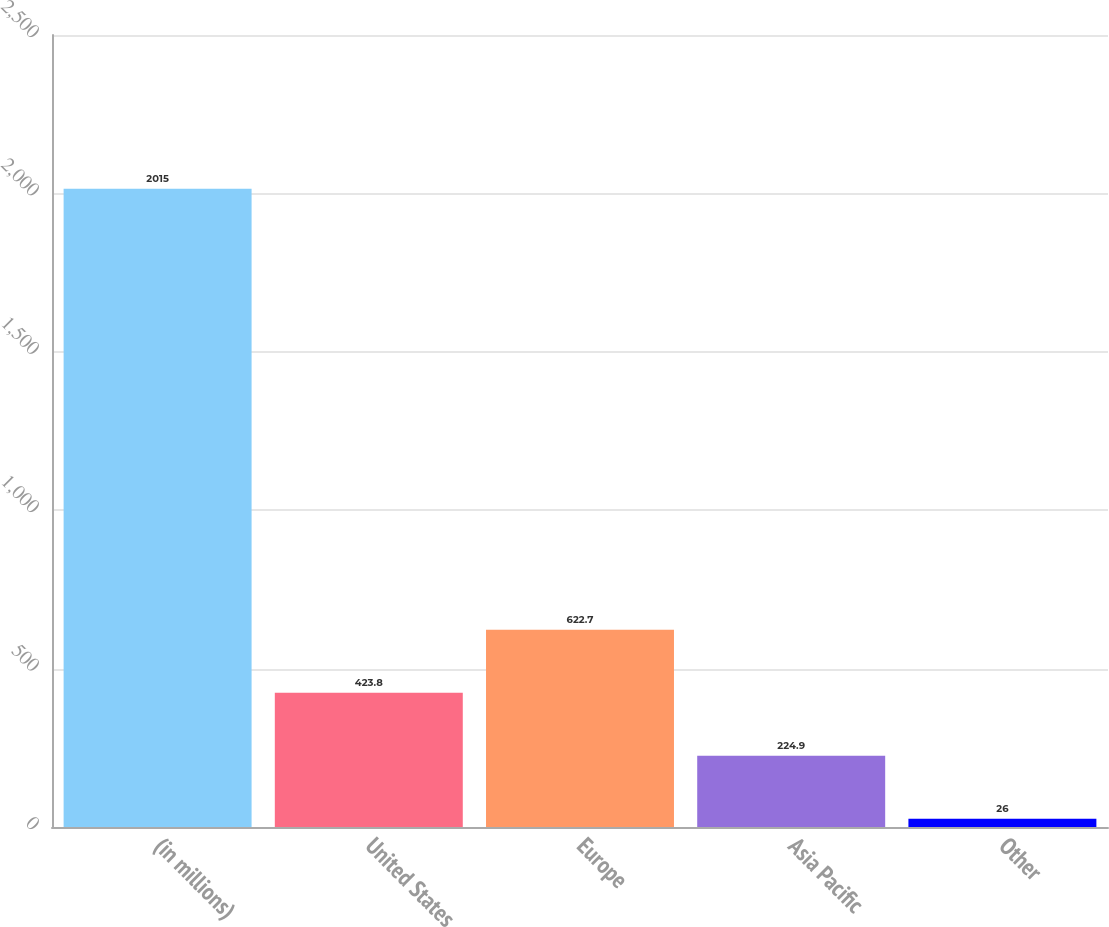Convert chart to OTSL. <chart><loc_0><loc_0><loc_500><loc_500><bar_chart><fcel>(in millions)<fcel>United States<fcel>Europe<fcel>Asia Pacific<fcel>Other<nl><fcel>2015<fcel>423.8<fcel>622.7<fcel>224.9<fcel>26<nl></chart> 